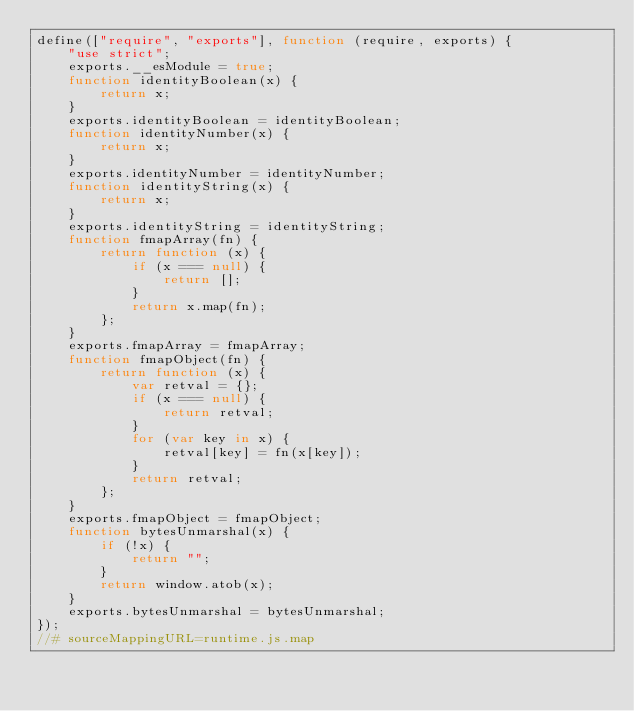Convert code to text. <code><loc_0><loc_0><loc_500><loc_500><_JavaScript_>define(["require", "exports"], function (require, exports) {
    "use strict";
    exports.__esModule = true;
    function identityBoolean(x) {
        return x;
    }
    exports.identityBoolean = identityBoolean;
    function identityNumber(x) {
        return x;
    }
    exports.identityNumber = identityNumber;
    function identityString(x) {
        return x;
    }
    exports.identityString = identityString;
    function fmapArray(fn) {
        return function (x) {
            if (x === null) {
                return [];
            }
            return x.map(fn);
        };
    }
    exports.fmapArray = fmapArray;
    function fmapObject(fn) {
        return function (x) {
            var retval = {};
            if (x === null) {
                return retval;
            }
            for (var key in x) {
                retval[key] = fn(x[key]);
            }
            return retval;
        };
    }
    exports.fmapObject = fmapObject;
    function bytesUnmarshal(x) {
        if (!x) {
            return "";
        }
        return window.atob(x);
    }
    exports.bytesUnmarshal = bytesUnmarshal;
});
//# sourceMappingURL=runtime.js.map</code> 